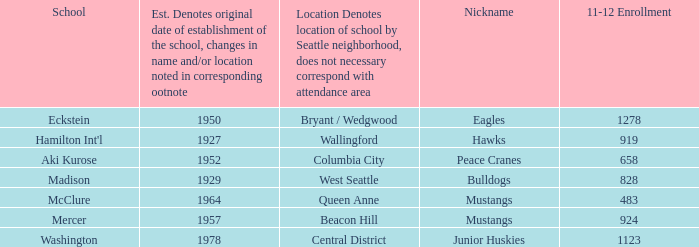Name the most 11-12 enrollment for columbia city 658.0. 